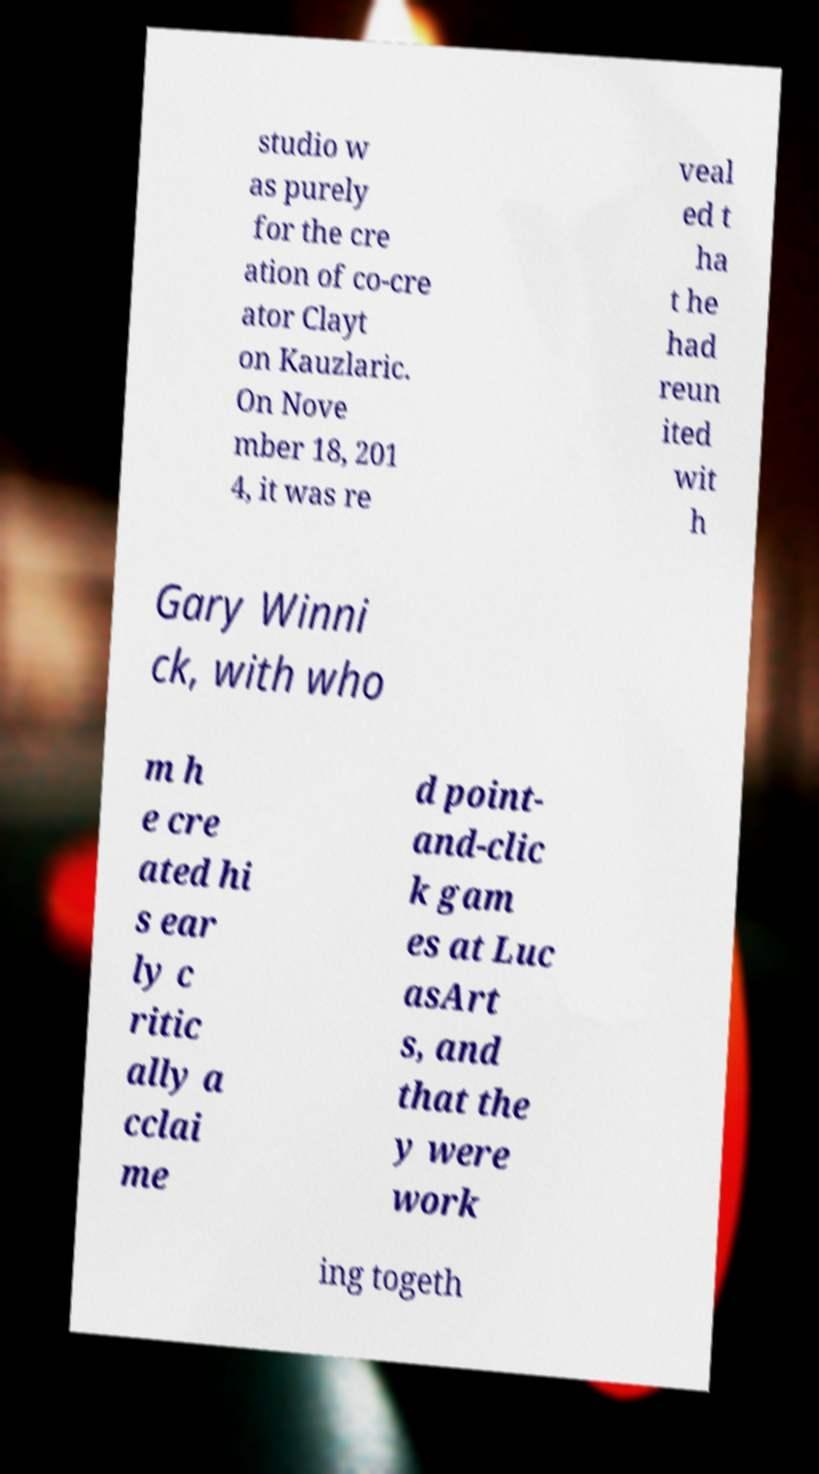For documentation purposes, I need the text within this image transcribed. Could you provide that? studio w as purely for the cre ation of co-cre ator Clayt on Kauzlaric. On Nove mber 18, 201 4, it was re veal ed t ha t he had reun ited wit h Gary Winni ck, with who m h e cre ated hi s ear ly c ritic ally a cclai me d point- and-clic k gam es at Luc asArt s, and that the y were work ing togeth 